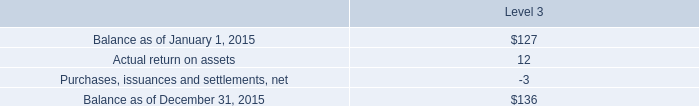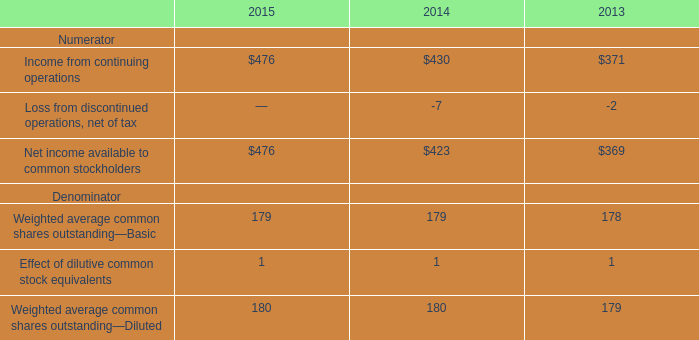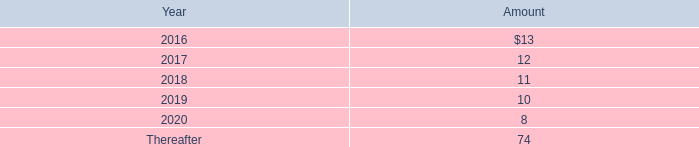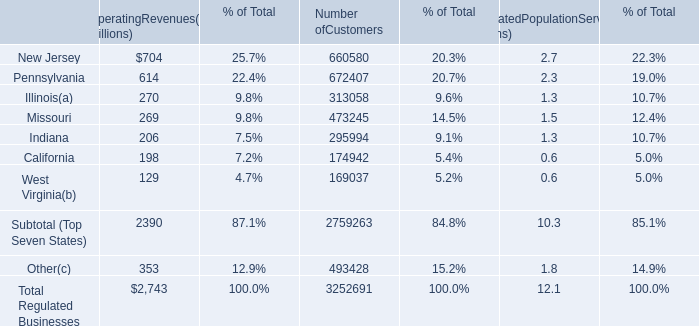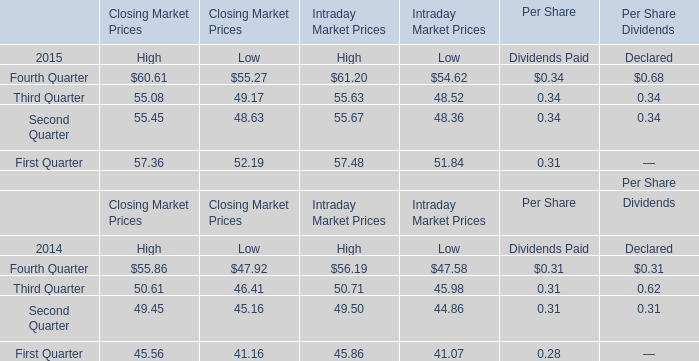what percentage does rental expense make up of gross cost of facilities funded in 2014? 
Computations: (22 / 157)
Answer: 0.14013. 